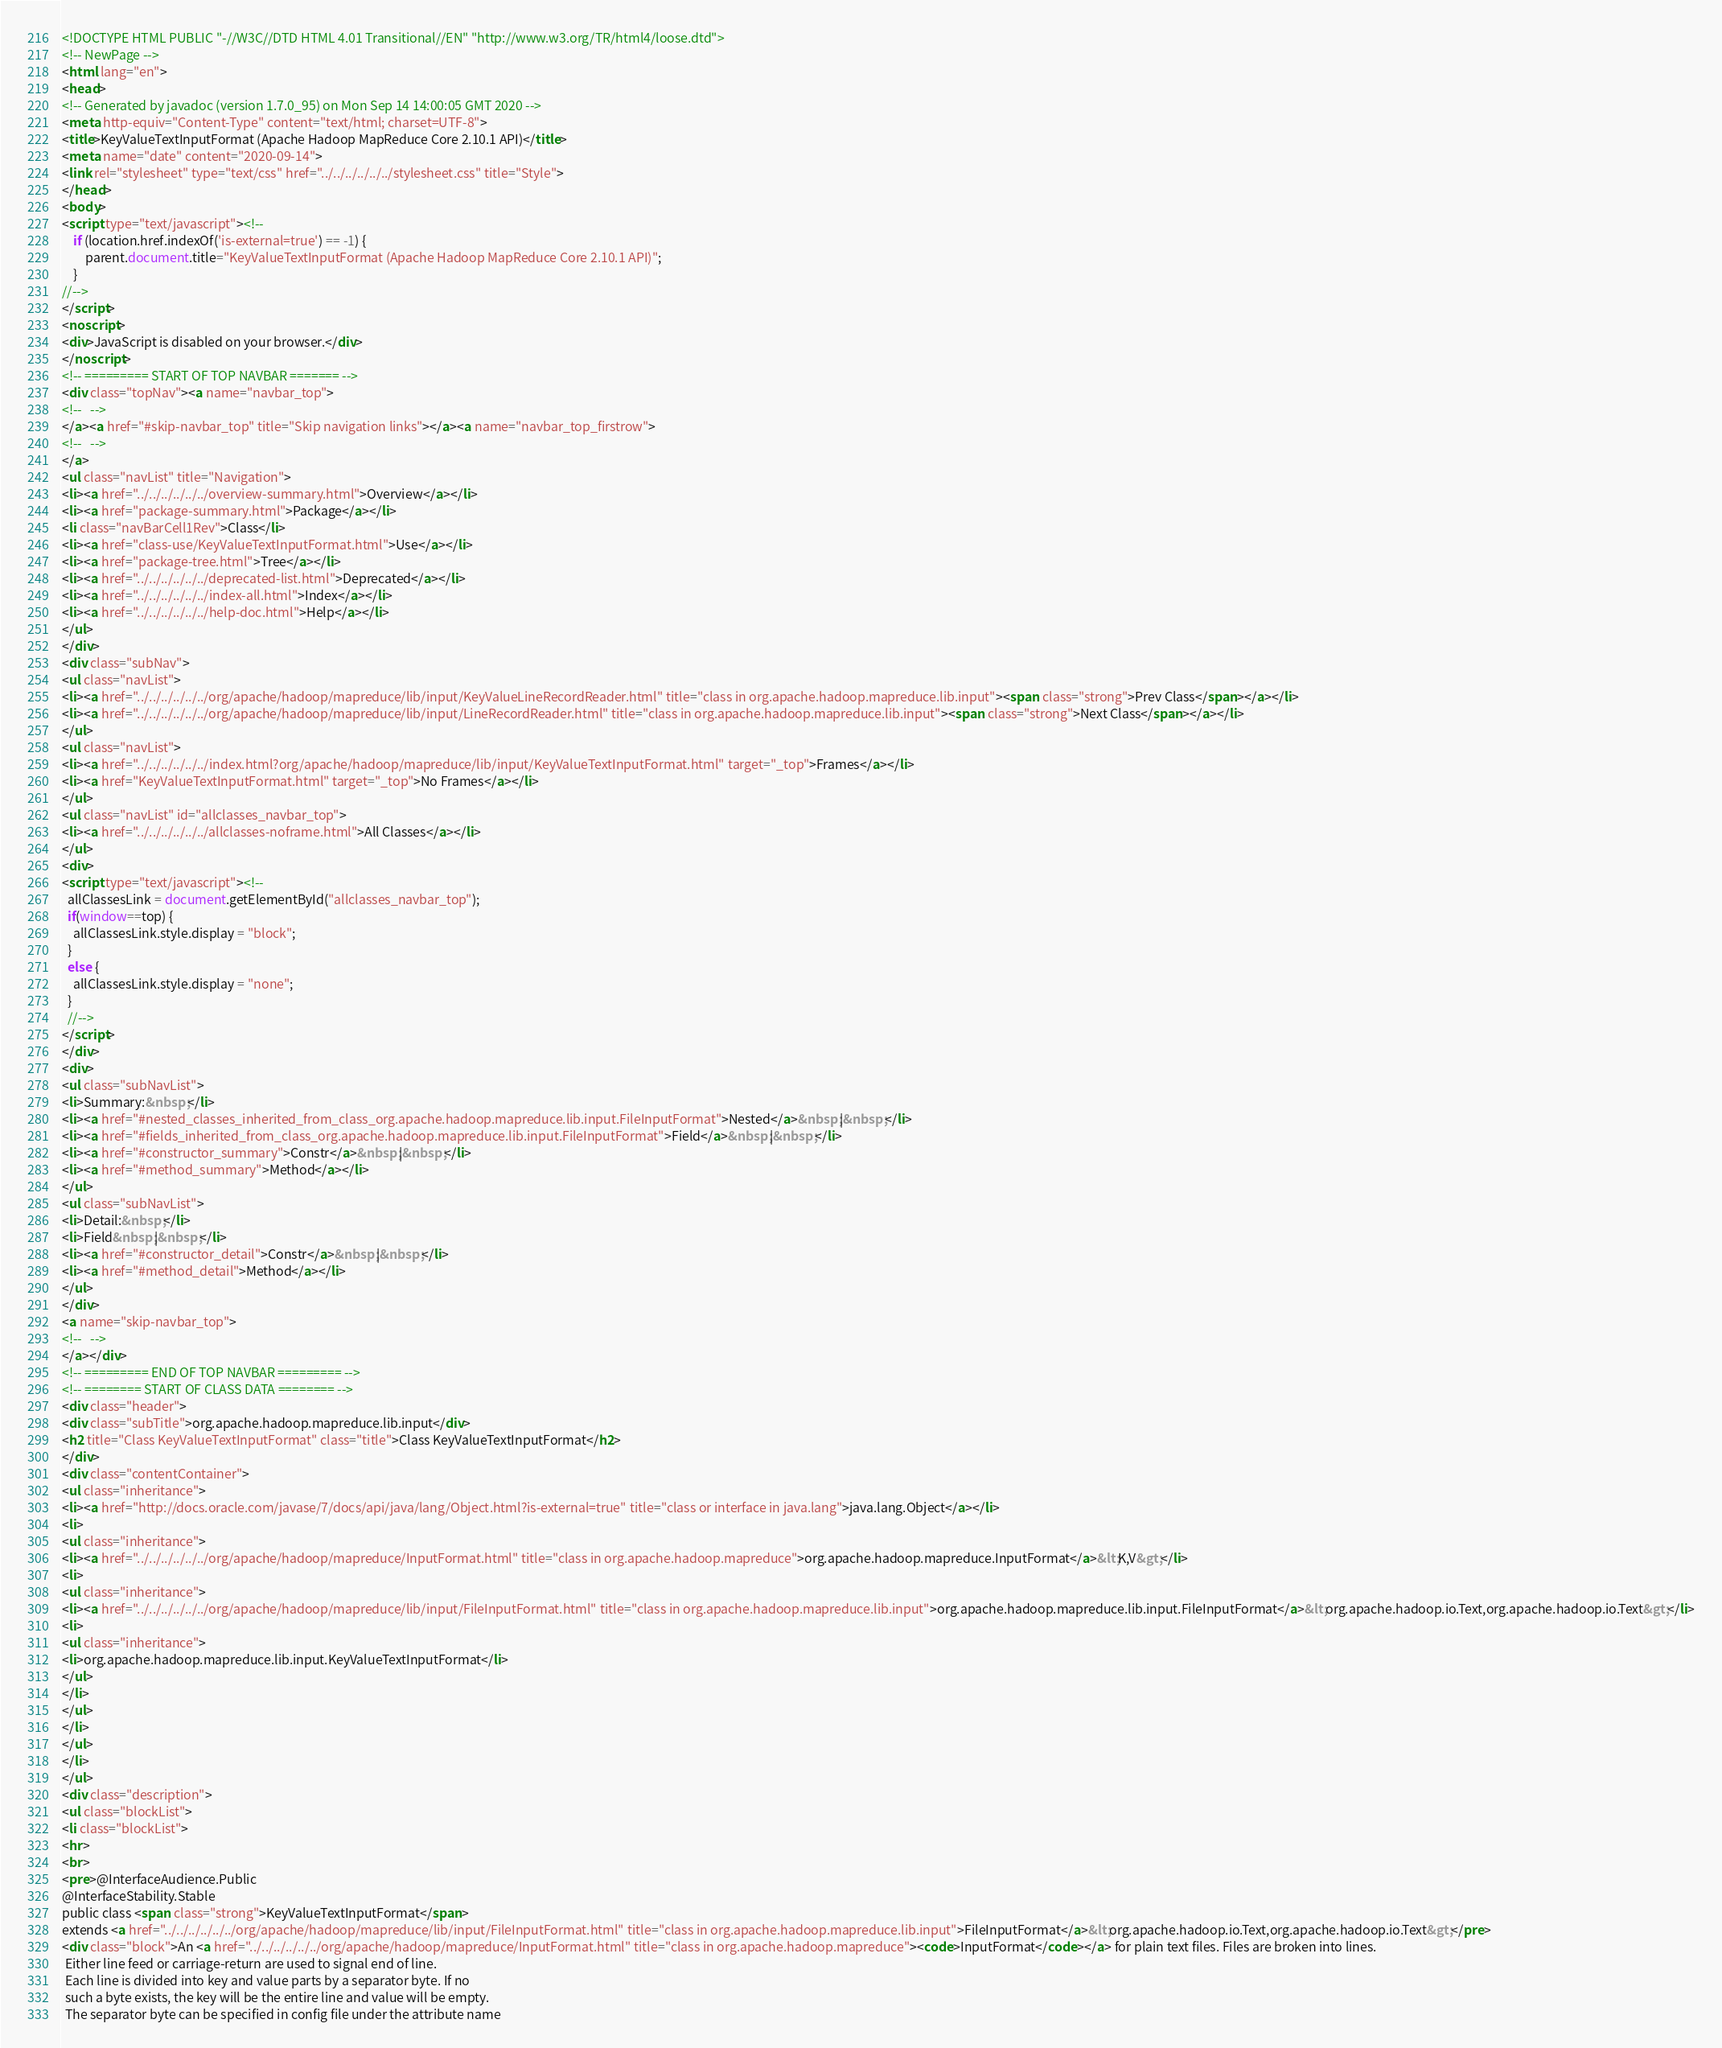Convert code to text. <code><loc_0><loc_0><loc_500><loc_500><_HTML_><!DOCTYPE HTML PUBLIC "-//W3C//DTD HTML 4.01 Transitional//EN" "http://www.w3.org/TR/html4/loose.dtd">
<!-- NewPage -->
<html lang="en">
<head>
<!-- Generated by javadoc (version 1.7.0_95) on Mon Sep 14 14:00:05 GMT 2020 -->
<meta http-equiv="Content-Type" content="text/html; charset=UTF-8">
<title>KeyValueTextInputFormat (Apache Hadoop MapReduce Core 2.10.1 API)</title>
<meta name="date" content="2020-09-14">
<link rel="stylesheet" type="text/css" href="../../../../../../stylesheet.css" title="Style">
</head>
<body>
<script type="text/javascript"><!--
    if (location.href.indexOf('is-external=true') == -1) {
        parent.document.title="KeyValueTextInputFormat (Apache Hadoop MapReduce Core 2.10.1 API)";
    }
//-->
</script>
<noscript>
<div>JavaScript is disabled on your browser.</div>
</noscript>
<!-- ========= START OF TOP NAVBAR ======= -->
<div class="topNav"><a name="navbar_top">
<!--   -->
</a><a href="#skip-navbar_top" title="Skip navigation links"></a><a name="navbar_top_firstrow">
<!--   -->
</a>
<ul class="navList" title="Navigation">
<li><a href="../../../../../../overview-summary.html">Overview</a></li>
<li><a href="package-summary.html">Package</a></li>
<li class="navBarCell1Rev">Class</li>
<li><a href="class-use/KeyValueTextInputFormat.html">Use</a></li>
<li><a href="package-tree.html">Tree</a></li>
<li><a href="../../../../../../deprecated-list.html">Deprecated</a></li>
<li><a href="../../../../../../index-all.html">Index</a></li>
<li><a href="../../../../../../help-doc.html">Help</a></li>
</ul>
</div>
<div class="subNav">
<ul class="navList">
<li><a href="../../../../../../org/apache/hadoop/mapreduce/lib/input/KeyValueLineRecordReader.html" title="class in org.apache.hadoop.mapreduce.lib.input"><span class="strong">Prev Class</span></a></li>
<li><a href="../../../../../../org/apache/hadoop/mapreduce/lib/input/LineRecordReader.html" title="class in org.apache.hadoop.mapreduce.lib.input"><span class="strong">Next Class</span></a></li>
</ul>
<ul class="navList">
<li><a href="../../../../../../index.html?org/apache/hadoop/mapreduce/lib/input/KeyValueTextInputFormat.html" target="_top">Frames</a></li>
<li><a href="KeyValueTextInputFormat.html" target="_top">No Frames</a></li>
</ul>
<ul class="navList" id="allclasses_navbar_top">
<li><a href="../../../../../../allclasses-noframe.html">All Classes</a></li>
</ul>
<div>
<script type="text/javascript"><!--
  allClassesLink = document.getElementById("allclasses_navbar_top");
  if(window==top) {
    allClassesLink.style.display = "block";
  }
  else {
    allClassesLink.style.display = "none";
  }
  //-->
</script>
</div>
<div>
<ul class="subNavList">
<li>Summary:&nbsp;</li>
<li><a href="#nested_classes_inherited_from_class_org.apache.hadoop.mapreduce.lib.input.FileInputFormat">Nested</a>&nbsp;|&nbsp;</li>
<li><a href="#fields_inherited_from_class_org.apache.hadoop.mapreduce.lib.input.FileInputFormat">Field</a>&nbsp;|&nbsp;</li>
<li><a href="#constructor_summary">Constr</a>&nbsp;|&nbsp;</li>
<li><a href="#method_summary">Method</a></li>
</ul>
<ul class="subNavList">
<li>Detail:&nbsp;</li>
<li>Field&nbsp;|&nbsp;</li>
<li><a href="#constructor_detail">Constr</a>&nbsp;|&nbsp;</li>
<li><a href="#method_detail">Method</a></li>
</ul>
</div>
<a name="skip-navbar_top">
<!--   -->
</a></div>
<!-- ========= END OF TOP NAVBAR ========= -->
<!-- ======== START OF CLASS DATA ======== -->
<div class="header">
<div class="subTitle">org.apache.hadoop.mapreduce.lib.input</div>
<h2 title="Class KeyValueTextInputFormat" class="title">Class KeyValueTextInputFormat</h2>
</div>
<div class="contentContainer">
<ul class="inheritance">
<li><a href="http://docs.oracle.com/javase/7/docs/api/java/lang/Object.html?is-external=true" title="class or interface in java.lang">java.lang.Object</a></li>
<li>
<ul class="inheritance">
<li><a href="../../../../../../org/apache/hadoop/mapreduce/InputFormat.html" title="class in org.apache.hadoop.mapreduce">org.apache.hadoop.mapreduce.InputFormat</a>&lt;K,V&gt;</li>
<li>
<ul class="inheritance">
<li><a href="../../../../../../org/apache/hadoop/mapreduce/lib/input/FileInputFormat.html" title="class in org.apache.hadoop.mapreduce.lib.input">org.apache.hadoop.mapreduce.lib.input.FileInputFormat</a>&lt;org.apache.hadoop.io.Text,org.apache.hadoop.io.Text&gt;</li>
<li>
<ul class="inheritance">
<li>org.apache.hadoop.mapreduce.lib.input.KeyValueTextInputFormat</li>
</ul>
</li>
</ul>
</li>
</ul>
</li>
</ul>
<div class="description">
<ul class="blockList">
<li class="blockList">
<hr>
<br>
<pre>@InterfaceAudience.Public
@InterfaceStability.Stable
public class <span class="strong">KeyValueTextInputFormat</span>
extends <a href="../../../../../../org/apache/hadoop/mapreduce/lib/input/FileInputFormat.html" title="class in org.apache.hadoop.mapreduce.lib.input">FileInputFormat</a>&lt;org.apache.hadoop.io.Text,org.apache.hadoop.io.Text&gt;</pre>
<div class="block">An <a href="../../../../../../org/apache/hadoop/mapreduce/InputFormat.html" title="class in org.apache.hadoop.mapreduce"><code>InputFormat</code></a> for plain text files. Files are broken into lines.
 Either line feed or carriage-return are used to signal end of line. 
 Each line is divided into key and value parts by a separator byte. If no
 such a byte exists, the key will be the entire line and value will be empty.
 The separator byte can be specified in config file under the attribute name</code> 